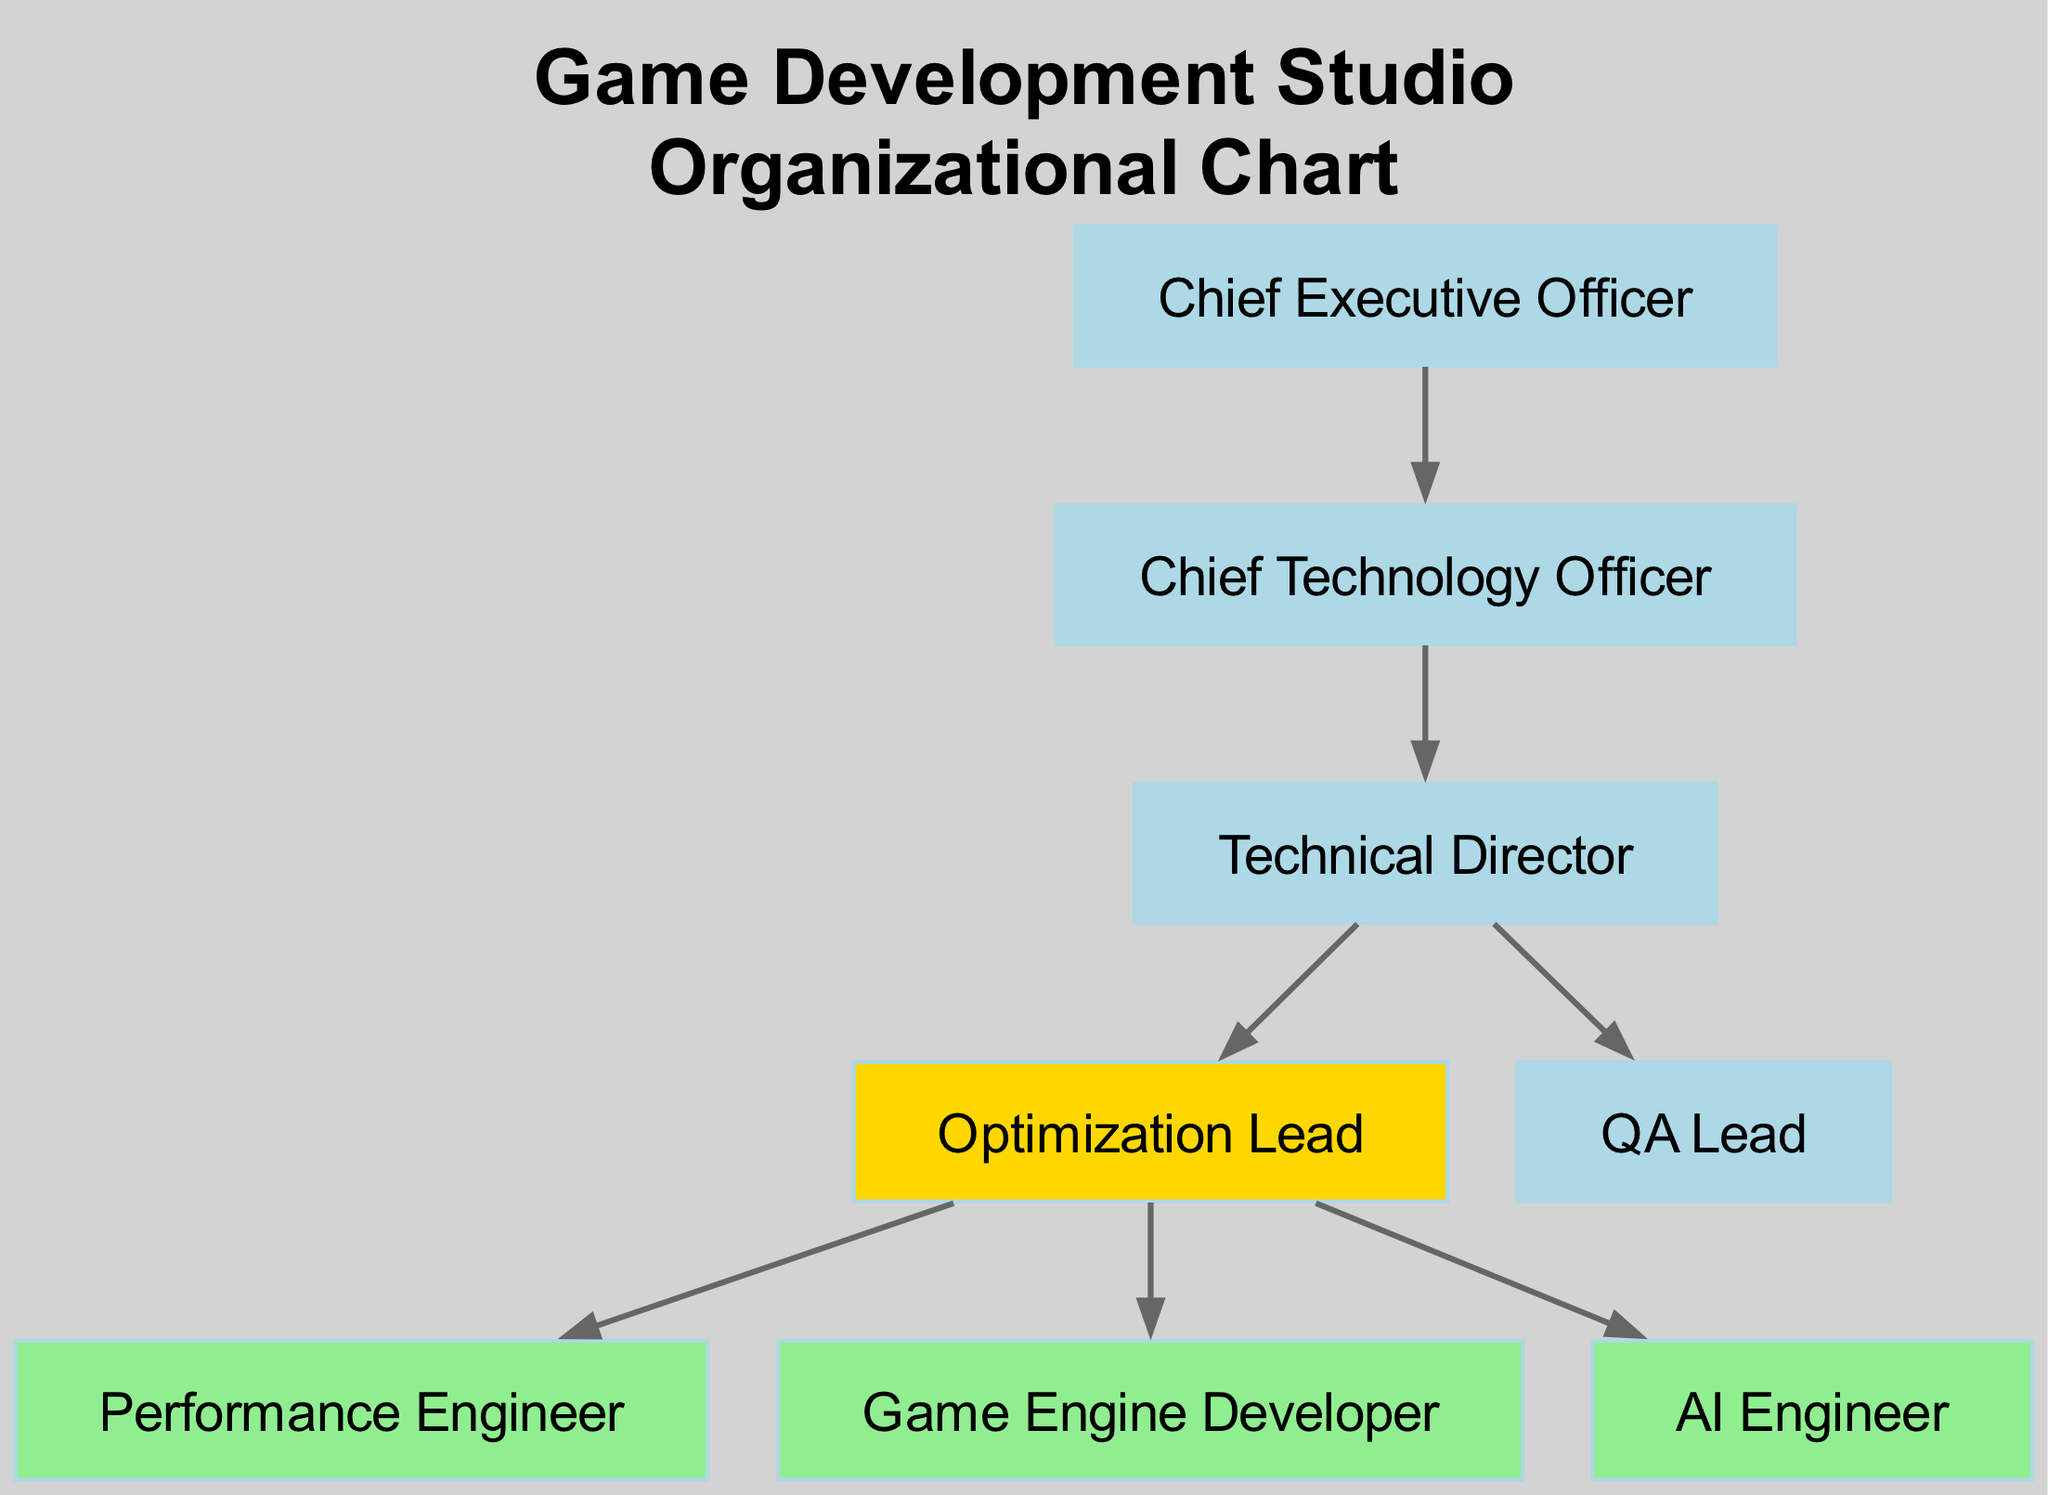What is the highest position in the organizational chart? The highest position is the Chief Executive Officer, which is represented at the top of the hierarchy in the diagram.
Answer: Chief Executive Officer How many nodes are in the diagram? The diagram contains 8 nodes, each representing different roles within the game development studio, including the CEO, CTO, Technical Director, and various specialized roles.
Answer: 8 Who reports directly to the Chief Technology Officer? The diagram shows that the Chief Technology Officer has two direct reports: the Technical Director and the QA Lead. Thus, the specific roles directly reporting to the CTO can be identified by tracing the edges from the CTO node.
Answer: Technical Director, QA Lead What team does the Optimization Lead manage? The Optimization Lead is responsible for the Performance Engineer, Game Engine Developer, and AI Engineer as indicated by the edges originating from the Optimization Lead node.
Answer: Performance Engineer, Game Engine Developer, AI Engineer Which role is responsible for managing performance in the studio? The Optimization Lead is designated in the diagram as the leader responsible for optimization, influencing the performance outcomes of the game development process.
Answer: Optimization Lead How many edges are leading from the Optimization Lead? By analyzing the diagram, we find three edges connecting from the Optimization Lead to three other nodes, indicating a direct connection to each of those roles.
Answer: 3 What color is used to highlight the Optimization Lead? The Optimization Lead is highlighted in gold in the diagram, which distinguishes it from other roles in the organization, indicating its importance within the optimization and performance team.
Answer: Gold Which organizational position is at the same level as the Optimization Lead? The Performance Engineer, Game Engine Developer, and AI Engineer all report to and are on the same level as the Optimization Lead in the hierarchy. This can be deduced by looking at the connections stemming from the Optimization Lead's position.
Answer: Performance Engineer, Game Engine Developer, AI Engineer 